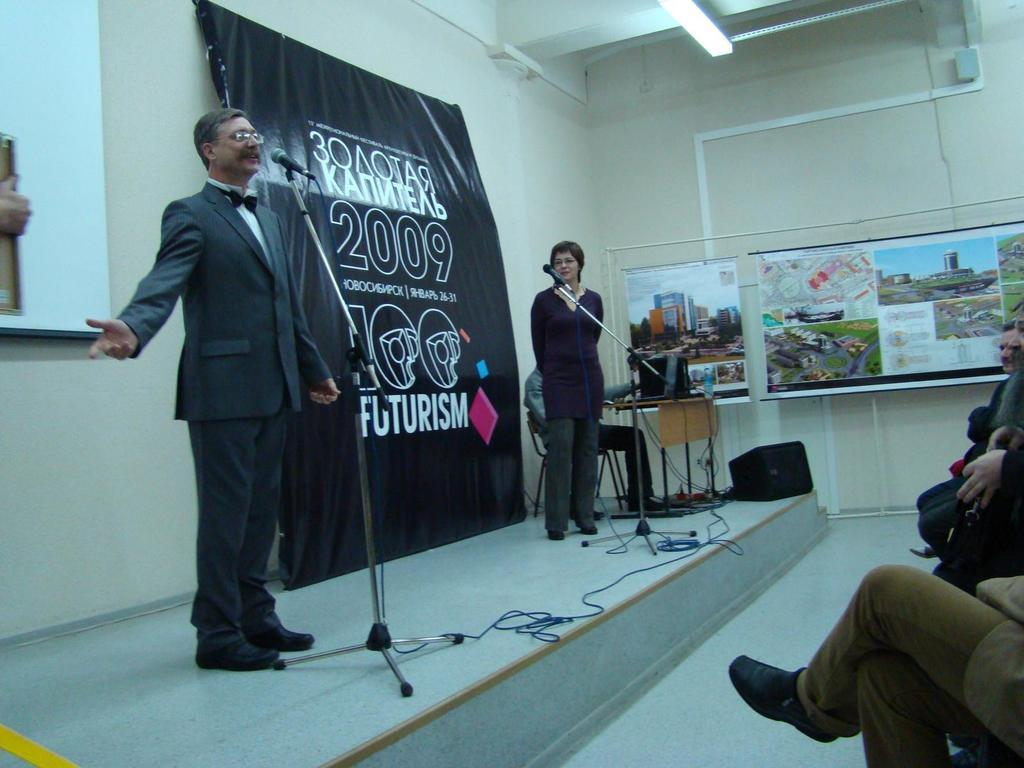<image>
Create a compact narrative representing the image presented. A man speaks on stage at a 2009 Futurism conference. 